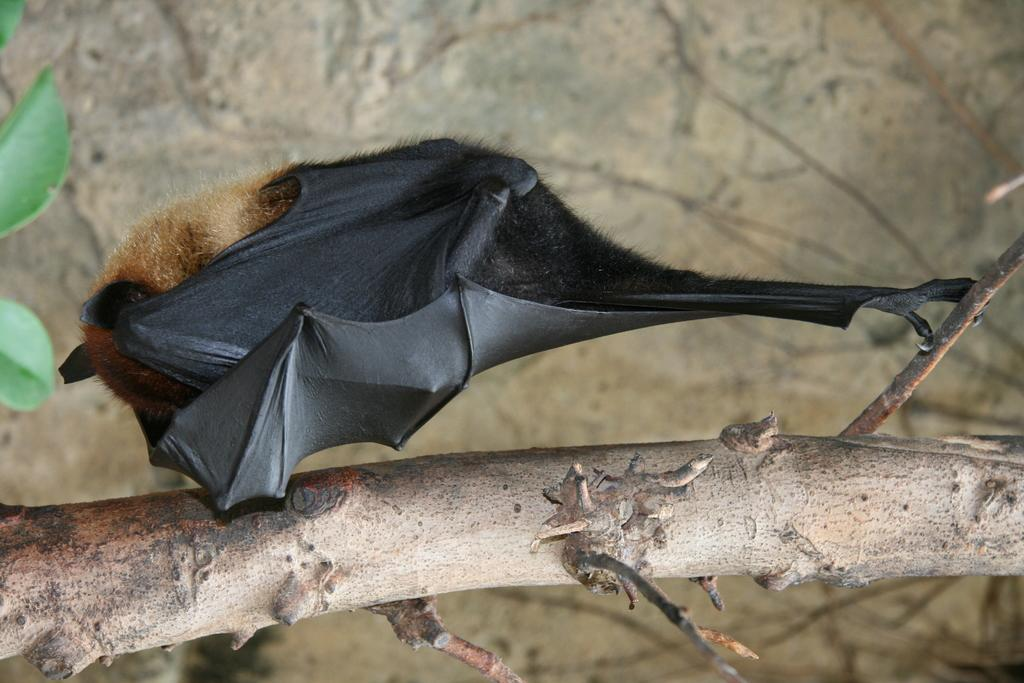What animal is in the image? There is a bat in the image. Where is the bat located? The bat is standing on a branch of a tree. What can be seen in the background of the image? There are leaves and an object that appears to be a wall visible in the background. What type of plough is being used by the bat in the image? There is no plough present in the image; it features a bat standing on a tree branch. What kind of structure is the bat using to fly in the image? The bat is not using any structure to fly in the image; it is standing on a tree branch. 